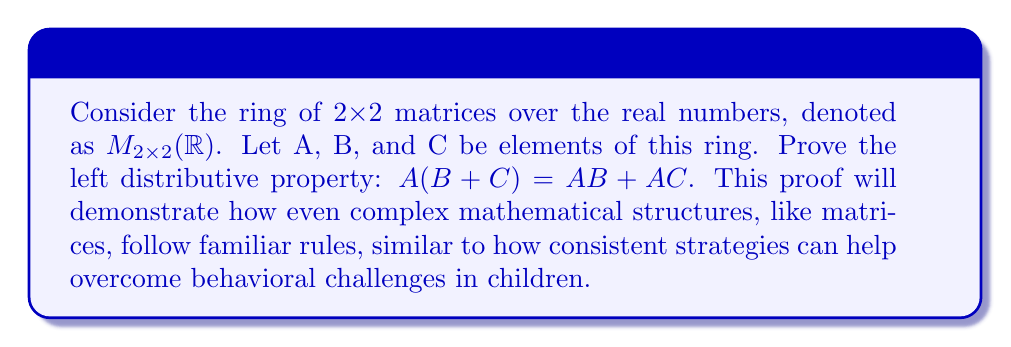Provide a solution to this math problem. To prove the left distributive property in the ring of 2x2 matrices over real numbers, we'll follow these steps:

1) Let's represent the matrices A, B, and C as:

   $A = \begin{pmatrix} a_{11} & a_{12} \\ a_{21} & a_{22} \end{pmatrix}$, 
   $B = \begin{pmatrix} b_{11} & b_{12} \\ b_{21} & b_{22} \end{pmatrix}$, 
   $C = \begin{pmatrix} c_{11} & c_{12} \\ c_{21} & c_{22} \end{pmatrix}$

2) First, let's calculate $B + C$:

   $B + C = \begin{pmatrix} b_{11}+c_{11} & b_{12}+c_{12} \\ b_{21}+c_{21} & b_{22}+c_{22} \end{pmatrix}$

3) Now, let's multiply $A(B + C)$:

   $A(B + C) = \begin{pmatrix} a_{11} & a_{12} \\ a_{21} & a_{22} \end{pmatrix} \begin{pmatrix} b_{11}+c_{11} & b_{12}+c_{12} \\ b_{21}+c_{21} & b_{22}+c_{22} \end{pmatrix}$

   $= \begin{pmatrix} 
   a_{11}(b_{11}+c_{11}) + a_{12}(b_{21}+c_{21}) & a_{11}(b_{12}+c_{12}) + a_{12}(b_{22}+c_{22}) \\
   a_{21}(b_{11}+c_{11}) + a_{22}(b_{21}+c_{21}) & a_{21}(b_{12}+c_{12}) + a_{22}(b_{22}+c_{22})
   \end{pmatrix}$

4) Next, let's calculate $AB$ and $AC$ separately:

   $AB = \begin{pmatrix} a_{11}b_{11} + a_{12}b_{21} & a_{11}b_{12} + a_{12}b_{22} \\ a_{21}b_{11} + a_{22}b_{21} & a_{21}b_{12} + a_{22}b_{22} \end{pmatrix}$

   $AC = \begin{pmatrix} a_{11}c_{11} + a_{12}c_{21} & a_{11}c_{12} + a_{12}c_{22} \\ a_{21}c_{11} + a_{22}c_{21} & a_{21}c_{12} + a_{22}c_{22} \end{pmatrix}$

5) Now, let's add $AB + AC$:

   $AB + AC = \begin{pmatrix} 
   (a_{11}b_{11} + a_{12}b_{21}) + (a_{11}c_{11} + a_{12}c_{21}) & (a_{11}b_{12} + a_{12}b_{22}) + (a_{11}c_{12} + a_{12}c_{22}) \\
   (a_{21}b_{11} + a_{22}b_{21}) + (a_{21}c_{11} + a_{22}c_{21}) & (a_{21}b_{12} + a_{22}b_{22}) + (a_{21}c_{12} + a_{22}c_{22})
   \end{pmatrix}$

   $= \begin{pmatrix} 
   a_{11}(b_{11}+c_{11}) + a_{12}(b_{21}+c_{21}) & a_{11}(b_{12}+c_{12}) + a_{12}(b_{22}+c_{22}) \\
   a_{21}(b_{11}+c_{11}) + a_{22}(b_{21}+c_{21}) & a_{21}(b_{12}+c_{12}) + a_{22}(b_{22}+c_{22})
   \end{pmatrix}$

6) We can see that the result of $AB + AC$ is identical to $A(B + C)$, thus proving the left distributive property in this ring.
Answer: The left distributive property $A(B + C) = AB + AC$ holds in the ring of 2x2 matrices over real numbers, $M_{2\times2}(\mathbb{R})$. 